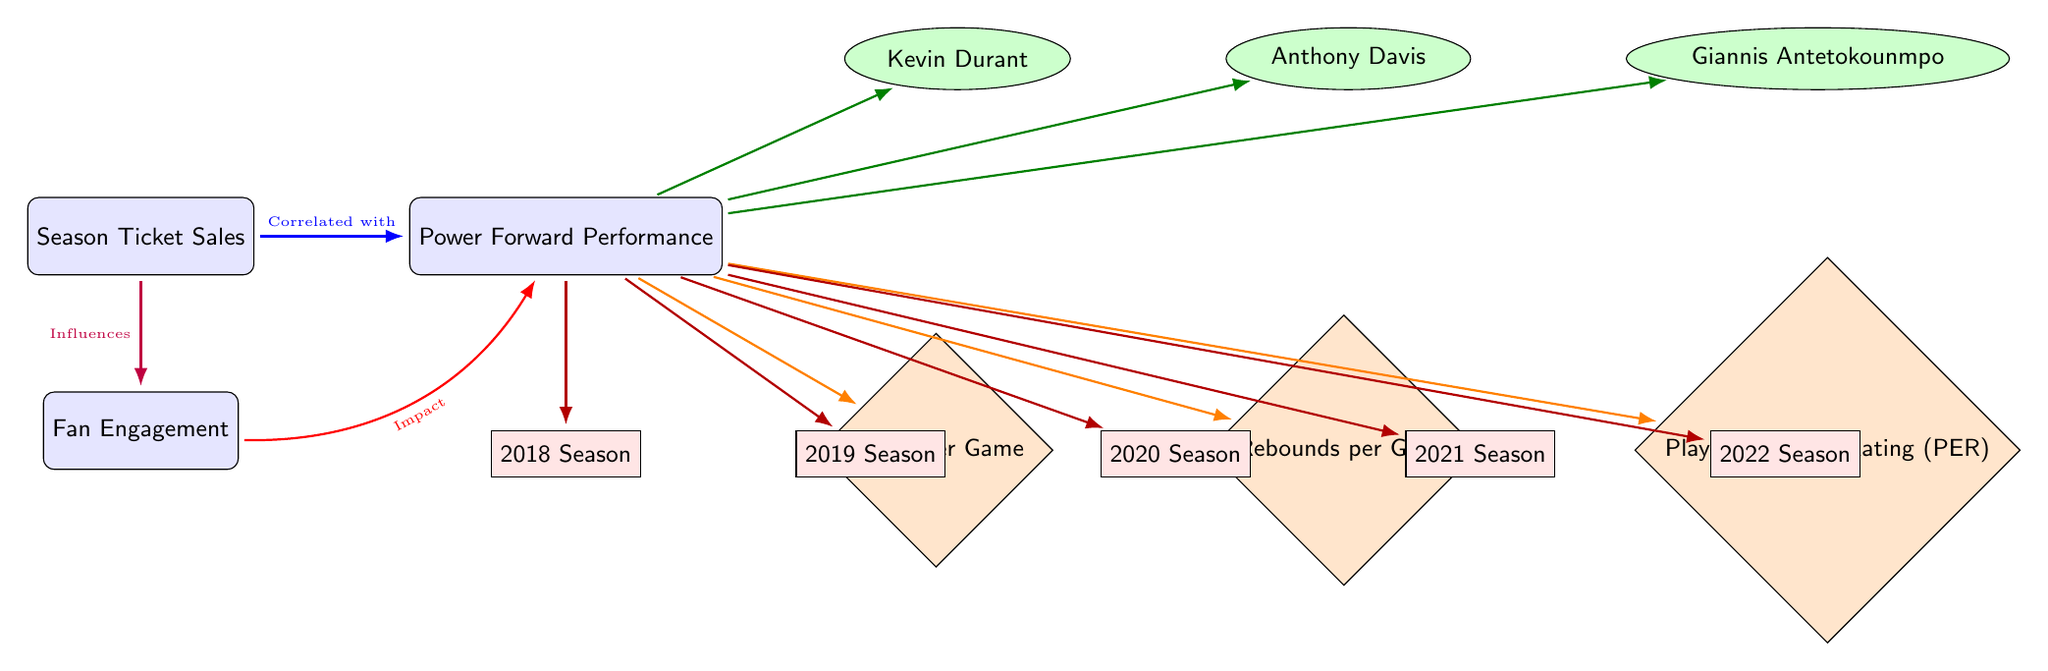How many players are connected to Power Forward Performance? The diagram shows three players directly connected to the Power Forward Performance node: Kevin Durant, Anthony Davis, and Giannis Antetokounmpo. Counting these players gives the total of three.
Answer: 3 What influences Fan Engagement? In the diagram, it is indicated that the Season Ticket Sales node influences the Fan Engagement node with a purple arrow. Therefore, Season Ticket Sales is the correct answer.
Answer: Season Ticket Sales Which performance metric is linked to Power Forward Performance by an orange arrow? The diagram shows three metrics connected to Power Forward Performance via orange arrows: Points per Game, Rebounds per Game, and Player Efficiency Rating (PER). Any one of these performance metrics would be a correct answer.
Answer: Points per Game In which season does the timeline start? The timeline node shows five seasons with the first being labeled as "2018 Season." Therefore, the starting point for the timeline is 2018.
Answer: 2018 Season What is the color of the node representing Season Ticket Sales? The Season Ticket Sales node is filled with a blue color according to the diagram's legend. So, the color associated with this node is blue.
Answer: Blue Which player has a direct influence on Season Ticket Sales? The diagram does not directly indicate that any of the players has an influence on Season Ticket Sales. Instead, it relates Season Ticket Sales to Power Forward Performance and Fan Engagement. Thus, there is no specific player responsible for influencing ticket sales directly.
Answer: None How does Power Forward Performance impact Fan Engagement? In the diagram, the connection from Power Forward Performance to Fan Engagement is shown with a red arrow bearing the description "Impact." This shows that there is a direct influence from Power Forward Performance on Fan Engagement.
Answer: Impact What are the three performance metrics associated with Power Forward Performance? The diagram lists three specific performance metrics connected to the Power Forward Performance node: Points per Game, Rebounds per Game, and Player Efficiency Rating (PER). Therefore, all three metrics are associated with the performance.
Answer: Points per Game, Rebounds per Game, Player Efficiency Rating 